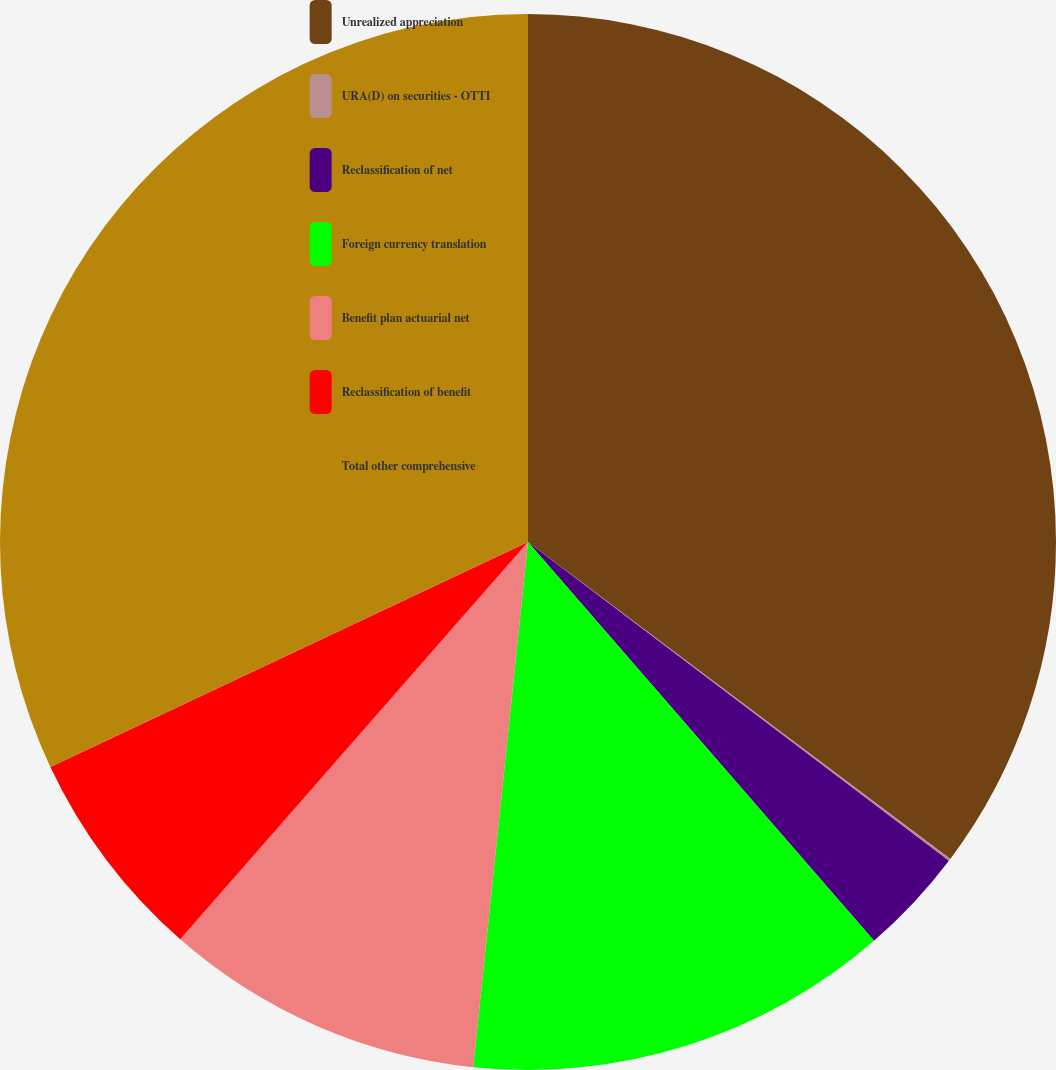Convert chart. <chart><loc_0><loc_0><loc_500><loc_500><pie_chart><fcel>Unrealized appreciation<fcel>URA(D) on securities - OTTI<fcel>Reclassification of net<fcel>Foreign currency translation<fcel>Benefit plan actuarial net<fcel>Reclassification of benefit<fcel>Total other comprehensive<nl><fcel>35.25%<fcel>0.07%<fcel>3.31%<fcel>13.03%<fcel>9.79%<fcel>6.55%<fcel>32.01%<nl></chart> 